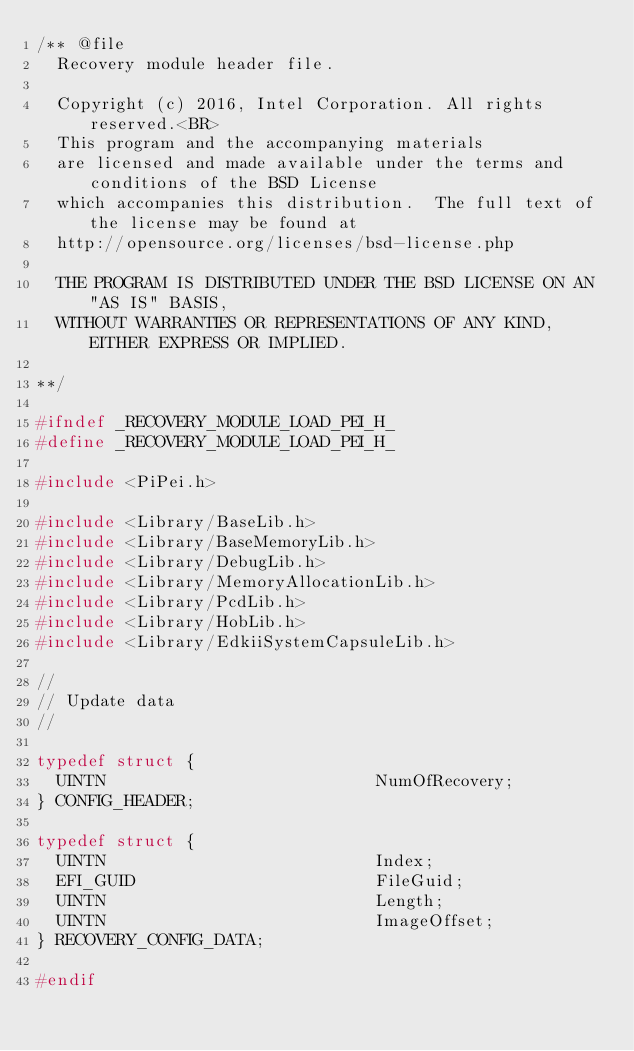Convert code to text. <code><loc_0><loc_0><loc_500><loc_500><_C_>/** @file
  Recovery module header file.

  Copyright (c) 2016, Intel Corporation. All rights reserved.<BR>
  This program and the accompanying materials
  are licensed and made available under the terms and conditions of the BSD License
  which accompanies this distribution.  The full text of the license may be found at
  http://opensource.org/licenses/bsd-license.php

  THE PROGRAM IS DISTRIBUTED UNDER THE BSD LICENSE ON AN "AS IS" BASIS,
  WITHOUT WARRANTIES OR REPRESENTATIONS OF ANY KIND, EITHER EXPRESS OR IMPLIED.

**/

#ifndef _RECOVERY_MODULE_LOAD_PEI_H_
#define _RECOVERY_MODULE_LOAD_PEI_H_

#include <PiPei.h>

#include <Library/BaseLib.h>
#include <Library/BaseMemoryLib.h>
#include <Library/DebugLib.h>
#include <Library/MemoryAllocationLib.h>
#include <Library/PcdLib.h>
#include <Library/HobLib.h>
#include <Library/EdkiiSystemCapsuleLib.h>

//
// Update data
//

typedef struct {
  UINTN                           NumOfRecovery;
} CONFIG_HEADER;

typedef struct {
  UINTN                           Index;
  EFI_GUID                        FileGuid;
  UINTN                           Length;
  UINTN                           ImageOffset;
} RECOVERY_CONFIG_DATA;

#endif

</code> 